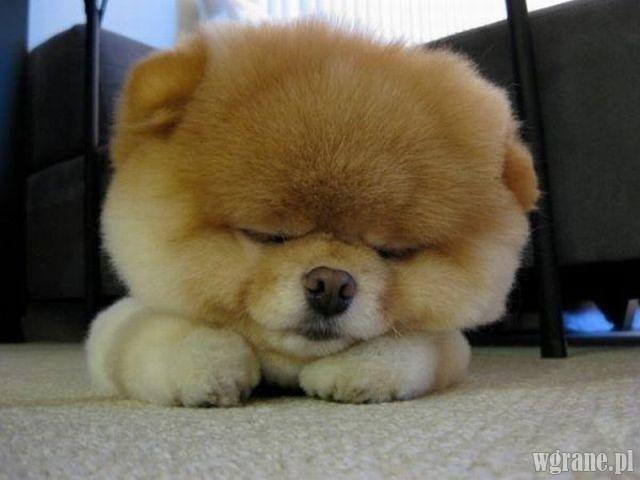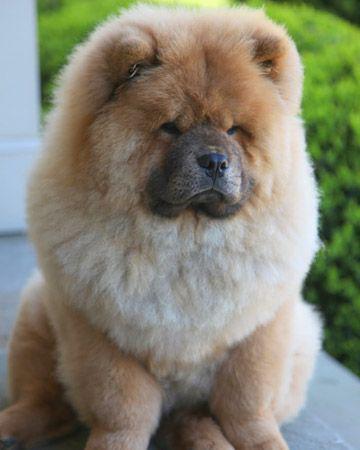The first image is the image on the left, the second image is the image on the right. Considering the images on both sides, is "The left and right image contains the same number of dogs with one being held in a woman's arms." valid? Answer yes or no. No. The first image is the image on the left, the second image is the image on the right. Given the left and right images, does the statement "A dog is laying in grass." hold true? Answer yes or no. No. 